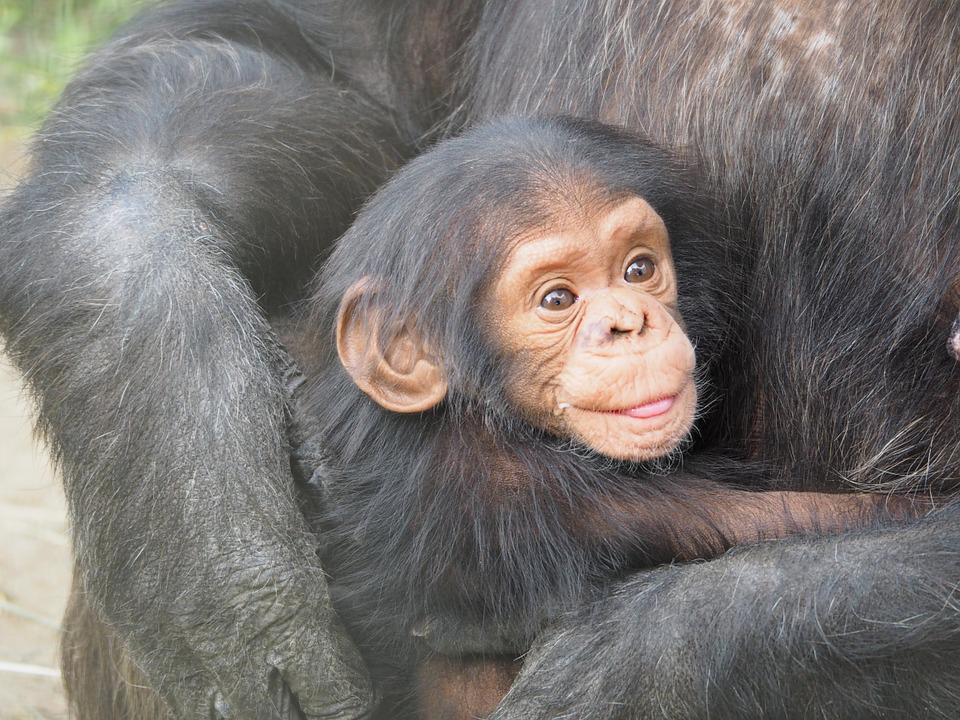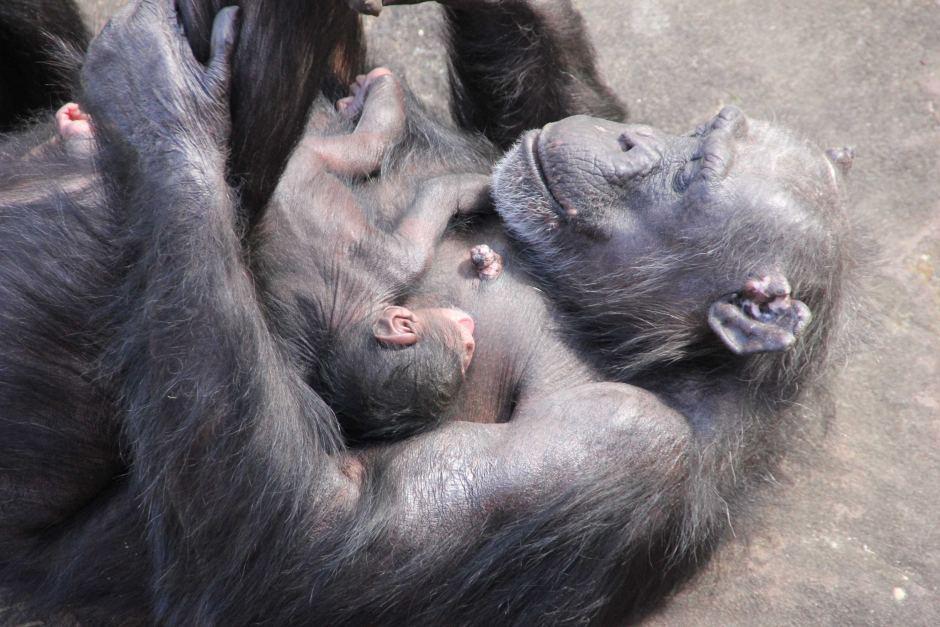The first image is the image on the left, the second image is the image on the right. Given the left and right images, does the statement "The right image shows an adult chimp sitting upright, with a baby held in front." hold true? Answer yes or no. No. 